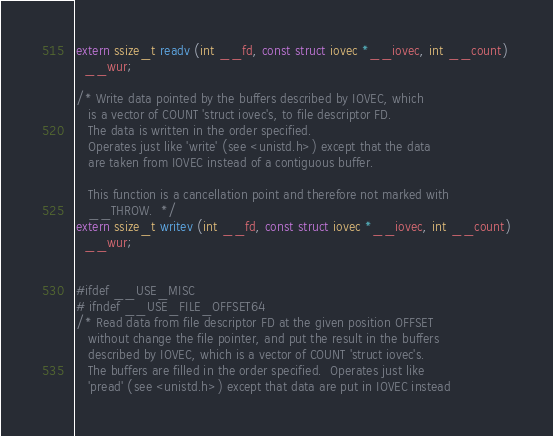<code> <loc_0><loc_0><loc_500><loc_500><_C_>extern ssize_t readv (int __fd, const struct iovec *__iovec, int __count)
  __wur;

/* Write data pointed by the buffers described by IOVEC, which
   is a vector of COUNT 'struct iovec's, to file descriptor FD.
   The data is written in the order specified.
   Operates just like 'write' (see <unistd.h>) except that the data
   are taken from IOVEC instead of a contiguous buffer.

   This function is a cancellation point and therefore not marked with
   __THROW.  */
extern ssize_t writev (int __fd, const struct iovec *__iovec, int __count)
  __wur;


#ifdef __USE_MISC
# ifndef __USE_FILE_OFFSET64
/* Read data from file descriptor FD at the given position OFFSET
   without change the file pointer, and put the result in the buffers
   described by IOVEC, which is a vector of COUNT 'struct iovec's.
   The buffers are filled in the order specified.  Operates just like
   'pread' (see <unistd.h>) except that data are put in IOVEC instead</code> 